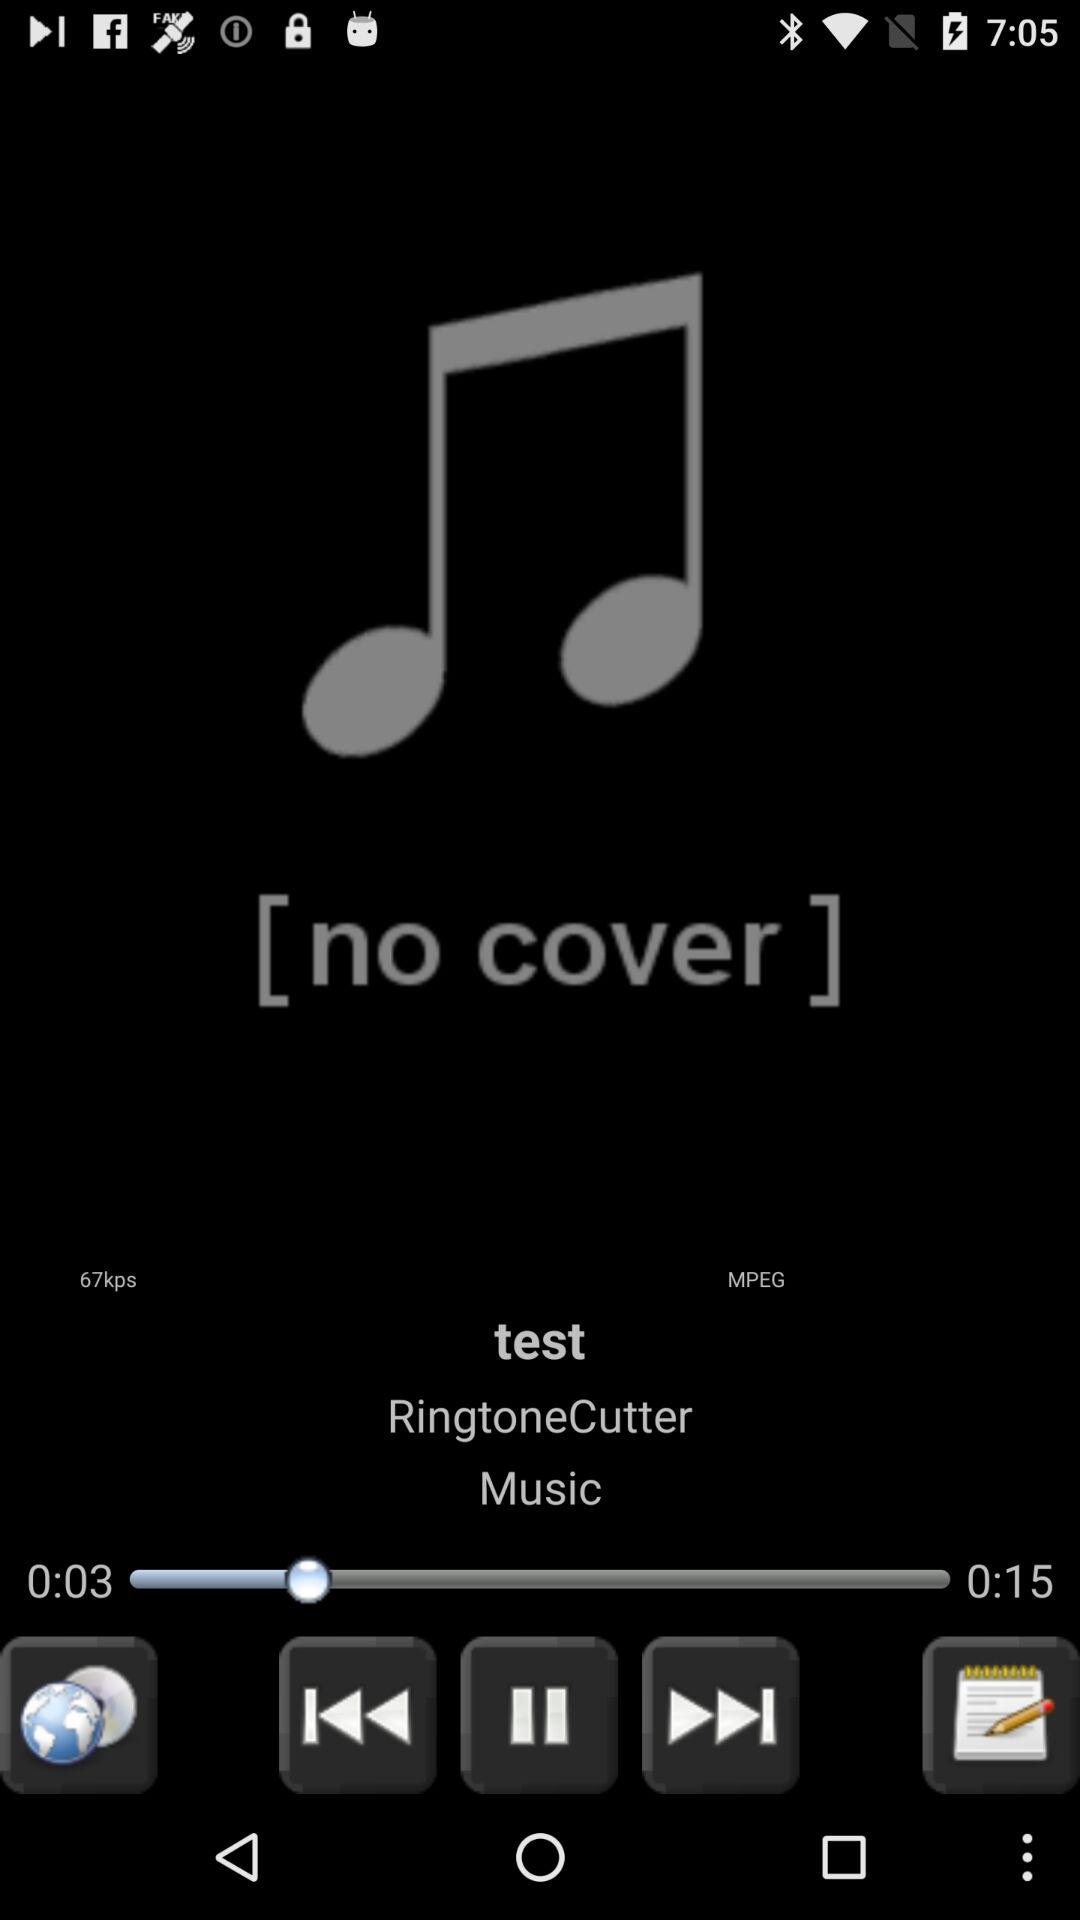How many kbps is the bitrate of the song?
Answer the question using a single word or phrase. 67kbps 